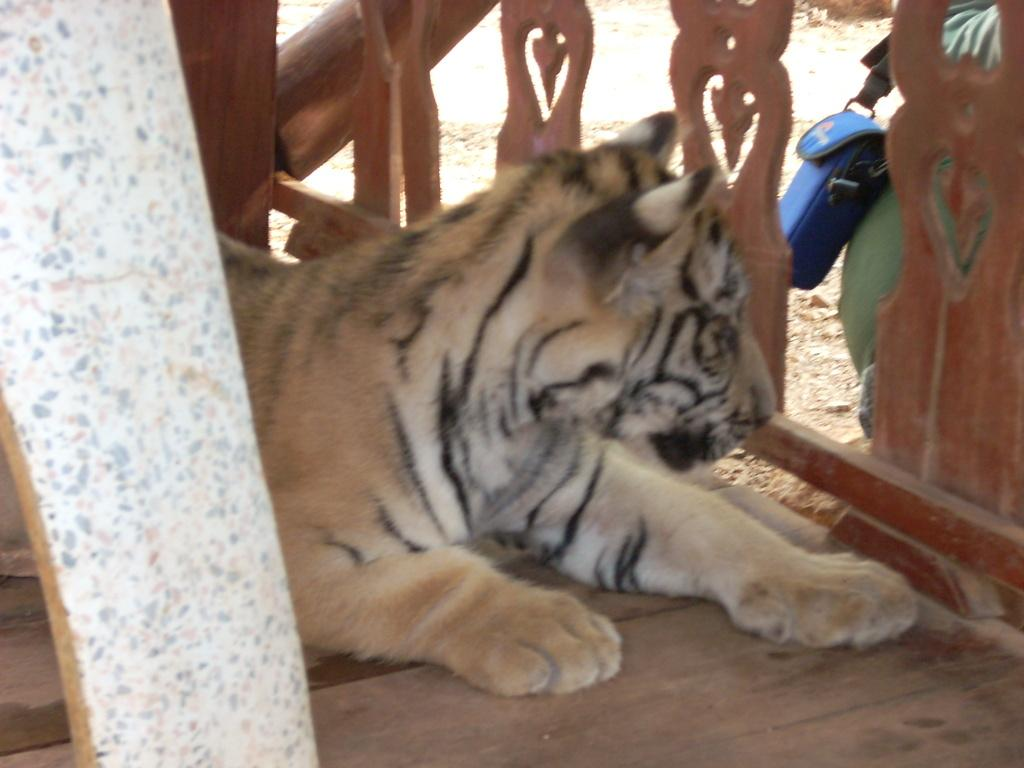What type of animal is in the image? There is a tiger in the image. What can be seen surrounding the tiger? There is a wooden frame in the image. What type of cloth is draped over the tiger in the image? There is no cloth draped over the tiger in the image; it is a tiger in its natural form. 